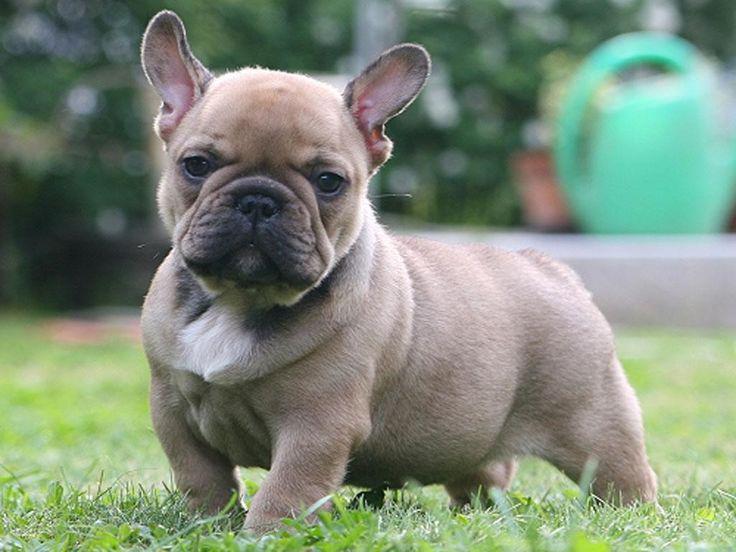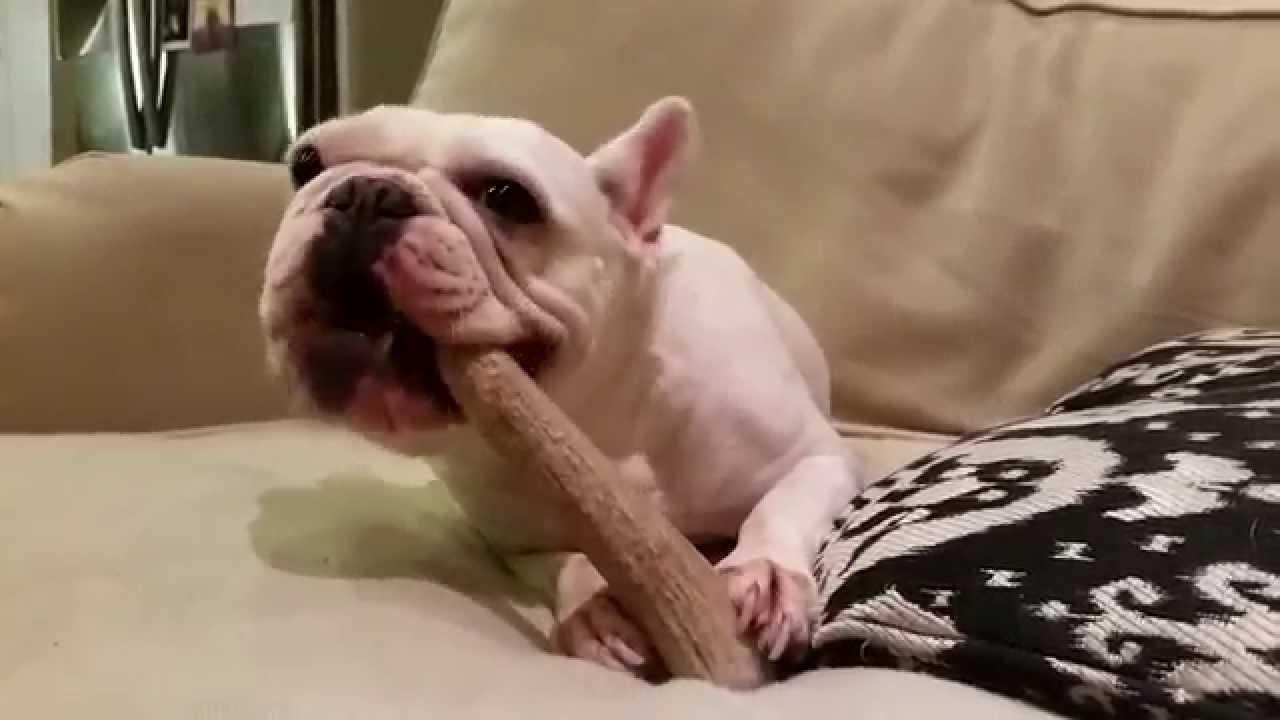The first image is the image on the left, the second image is the image on the right. Considering the images on both sides, is "Each picture includes more than one mammal." valid? Answer yes or no. No. The first image is the image on the left, the second image is the image on the right. Analyze the images presented: Is the assertion "A total of one French Bulldog has something in its mouth." valid? Answer yes or no. Yes. 